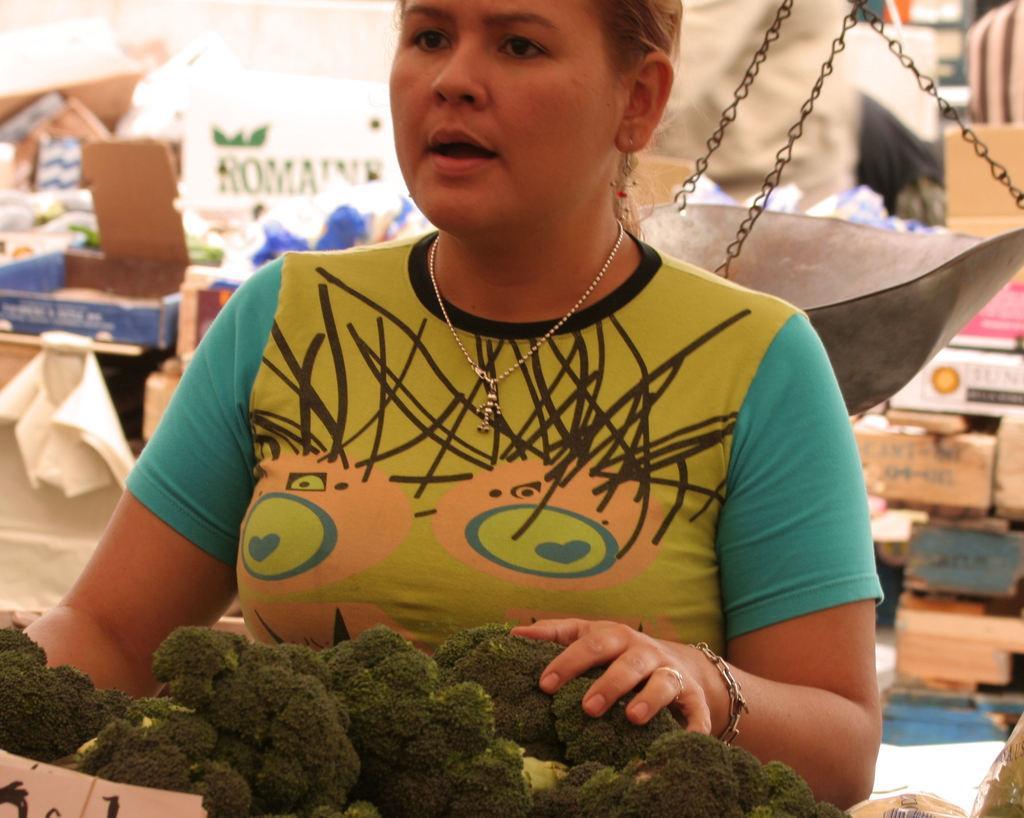Describe this image in one or two sentences. In this image there is a person standing. There are vegetables in the foreground. There is a weighing machine. There are many boxes in the background. 